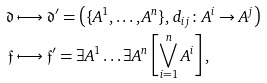<formula> <loc_0><loc_0><loc_500><loc_500>\mathfrak { d } & \longmapsto \mathfrak { d } ^ { \prime } = \left ( \{ A ^ { 1 } , \dots , A ^ { n } \} , d _ { i j } \colon A ^ { i } \rightarrow A ^ { j } \right ) \\ \mathfrak { f } & \longmapsto \mathfrak { f } ^ { \prime } = \exists A ^ { 1 } \dots \exists A ^ { n } \left [ \bigvee _ { i = 1 } ^ { n } A ^ { i } \right ] ,</formula> 